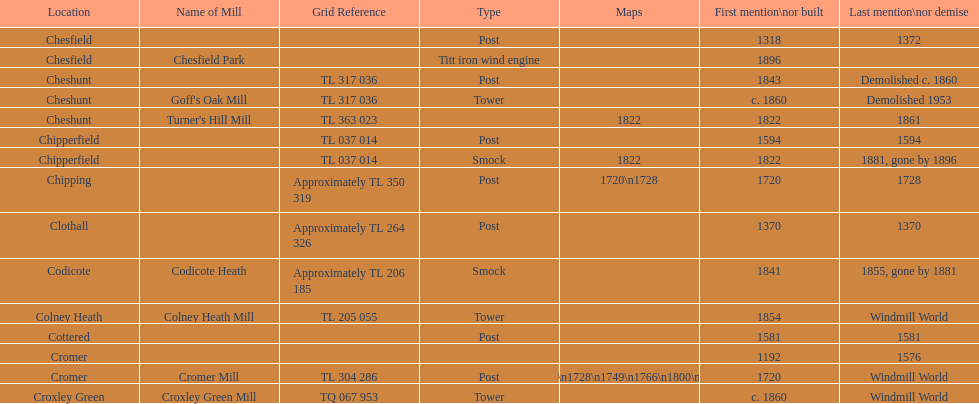How man "c" windmills have there been? 15. 